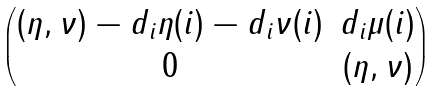Convert formula to latex. <formula><loc_0><loc_0><loc_500><loc_500>\begin{pmatrix} ( \eta , \nu ) - d _ { i } \eta ( i ) - d _ { i } \nu ( i ) & d _ { i } \mu ( i ) \\ 0 & ( \eta , \nu ) \end{pmatrix}</formula> 